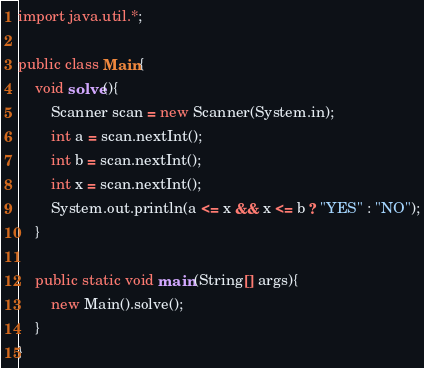<code> <loc_0><loc_0><loc_500><loc_500><_Java_>import java.util.*;

public class Main{
    void solve(){
        Scanner scan = new Scanner(System.in);
        int a = scan.nextInt();
        int b = scan.nextInt();
        int x = scan.nextInt();
        System.out.println(a <= x && x <= b ? "YES" : "NO");
    }
    
    public static void main(String[] args){
        new Main().solve();
    }
}</code> 